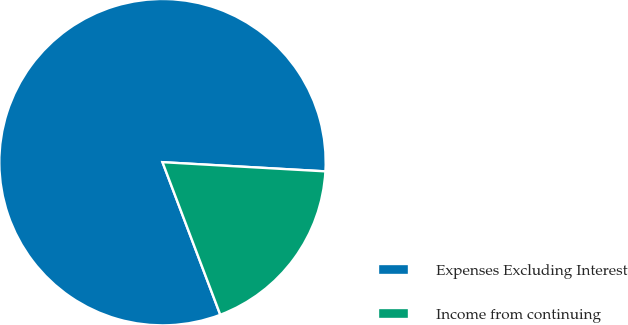Convert chart. <chart><loc_0><loc_0><loc_500><loc_500><pie_chart><fcel>Expenses Excluding Interest<fcel>Income from continuing<nl><fcel>81.66%<fcel>18.34%<nl></chart> 